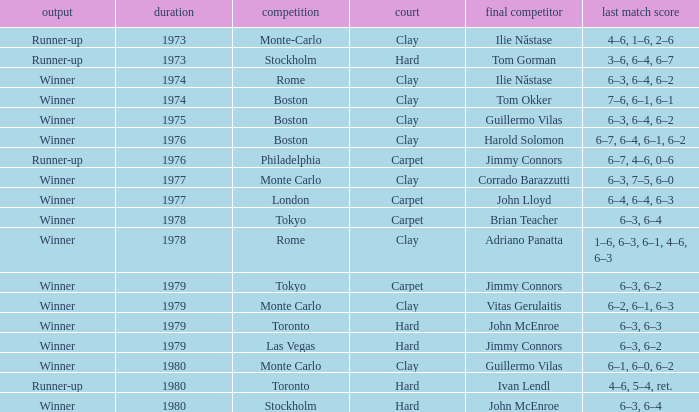Name the number of year for 6–3, 6–2 hard surface 1.0. 